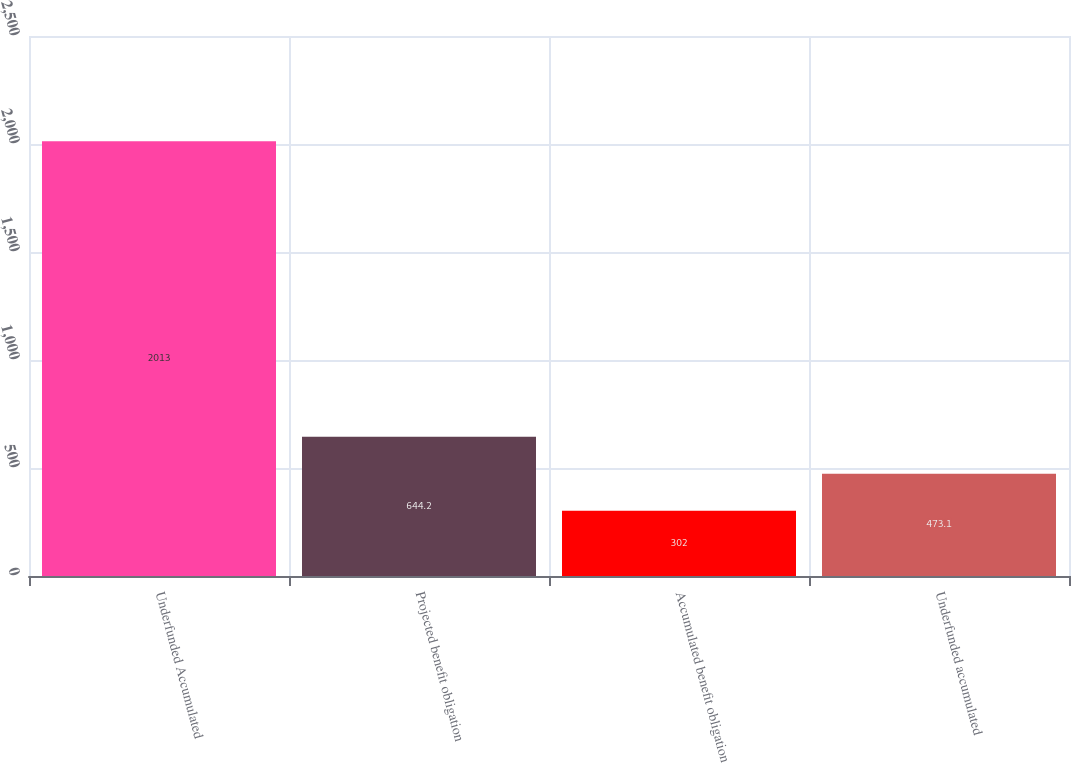<chart> <loc_0><loc_0><loc_500><loc_500><bar_chart><fcel>Underfunded Accumulated<fcel>Projected benefit obligation<fcel>Accumulated benefit obligation<fcel>Underfunded accumulated<nl><fcel>2013<fcel>644.2<fcel>302<fcel>473.1<nl></chart> 